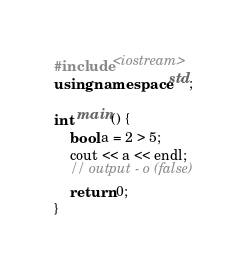Convert code to text. <code><loc_0><loc_0><loc_500><loc_500><_C++_>#include <iostream>
using namespace std;

int main() {
    bool a = 2 > 5;
    cout << a << endl;
    // output - o (false)
    return 0;
}</code> 